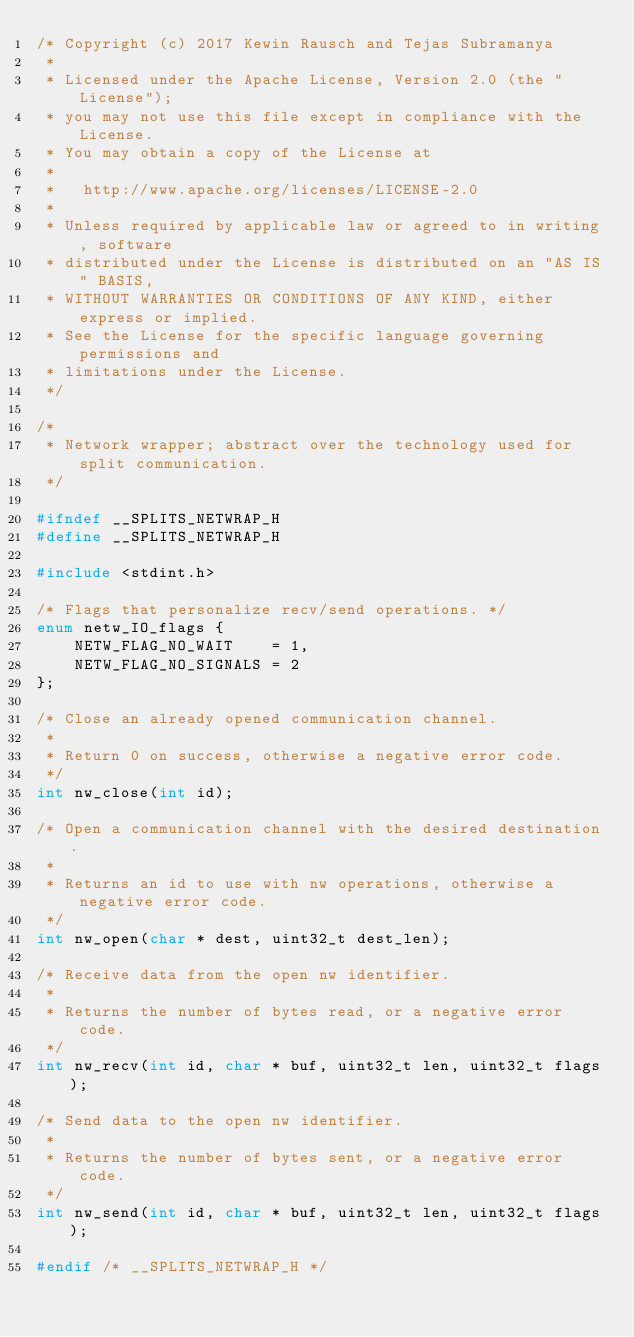<code> <loc_0><loc_0><loc_500><loc_500><_C_>/* Copyright (c) 2017 Kewin Rausch and Tejas Subramanya
 *
 * Licensed under the Apache License, Version 2.0 (the "License");
 * you may not use this file except in compliance with the License.
 * You may obtain a copy of the License at
 *
 *   http://www.apache.org/licenses/LICENSE-2.0
 *
 * Unless required by applicable law or agreed to in writing, software
 * distributed under the License is distributed on an "AS IS" BASIS,
 * WITHOUT WARRANTIES OR CONDITIONS OF ANY KIND, either express or implied.
 * See the License for the specific language governing permissions and
 * limitations under the License.
 */

/*
 * Network wrapper; abstract over the technology used for split communication.
 */

#ifndef __SPLITS_NETWRAP_H
#define __SPLITS_NETWRAP_H

#include <stdint.h>

/* Flags that personalize recv/send operations. */
enum netw_IO_flags {
	NETW_FLAG_NO_WAIT    = 1,
	NETW_FLAG_NO_SIGNALS = 2
};

/* Close an already opened communication channel.
 *
 * Return 0 on success, otherwise a negative error code.
 */
int nw_close(int id);

/* Open a communication channel with the desired destination.
 *
 * Returns an id to use with nw operations, otherwise a negative error code.
 */
int nw_open(char * dest, uint32_t dest_len);

/* Receive data from the open nw identifier.
 *
 * Returns the number of bytes read, or a negative error code.
 */
int nw_recv(int id, char * buf, uint32_t len, uint32_t flags);

/* Send data to the open nw identifier.
 *
 * Returns the number of bytes sent, or a negative error code.
 */
int nw_send(int id, char * buf, uint32_t len, uint32_t flags);

#endif /* __SPLITS_NETWRAP_H */
</code> 